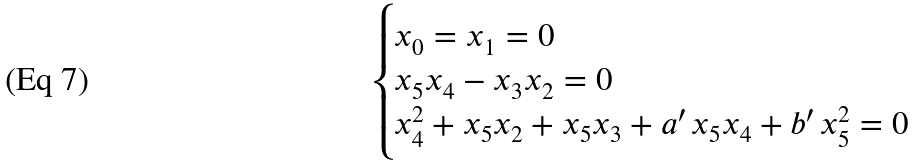<formula> <loc_0><loc_0><loc_500><loc_500>\begin{cases} x _ { 0 } = x _ { 1 } = 0 \\ x _ { 5 } x _ { 4 } - x _ { 3 } x _ { 2 } = 0 \\ x _ { 4 } ^ { 2 } + x _ { 5 } x _ { 2 } + x _ { 5 } x _ { 3 } + a ^ { \prime } \, x _ { 5 } x _ { 4 } + b ^ { \prime } \, x _ { 5 } ^ { 2 } = 0 \end{cases}</formula> 